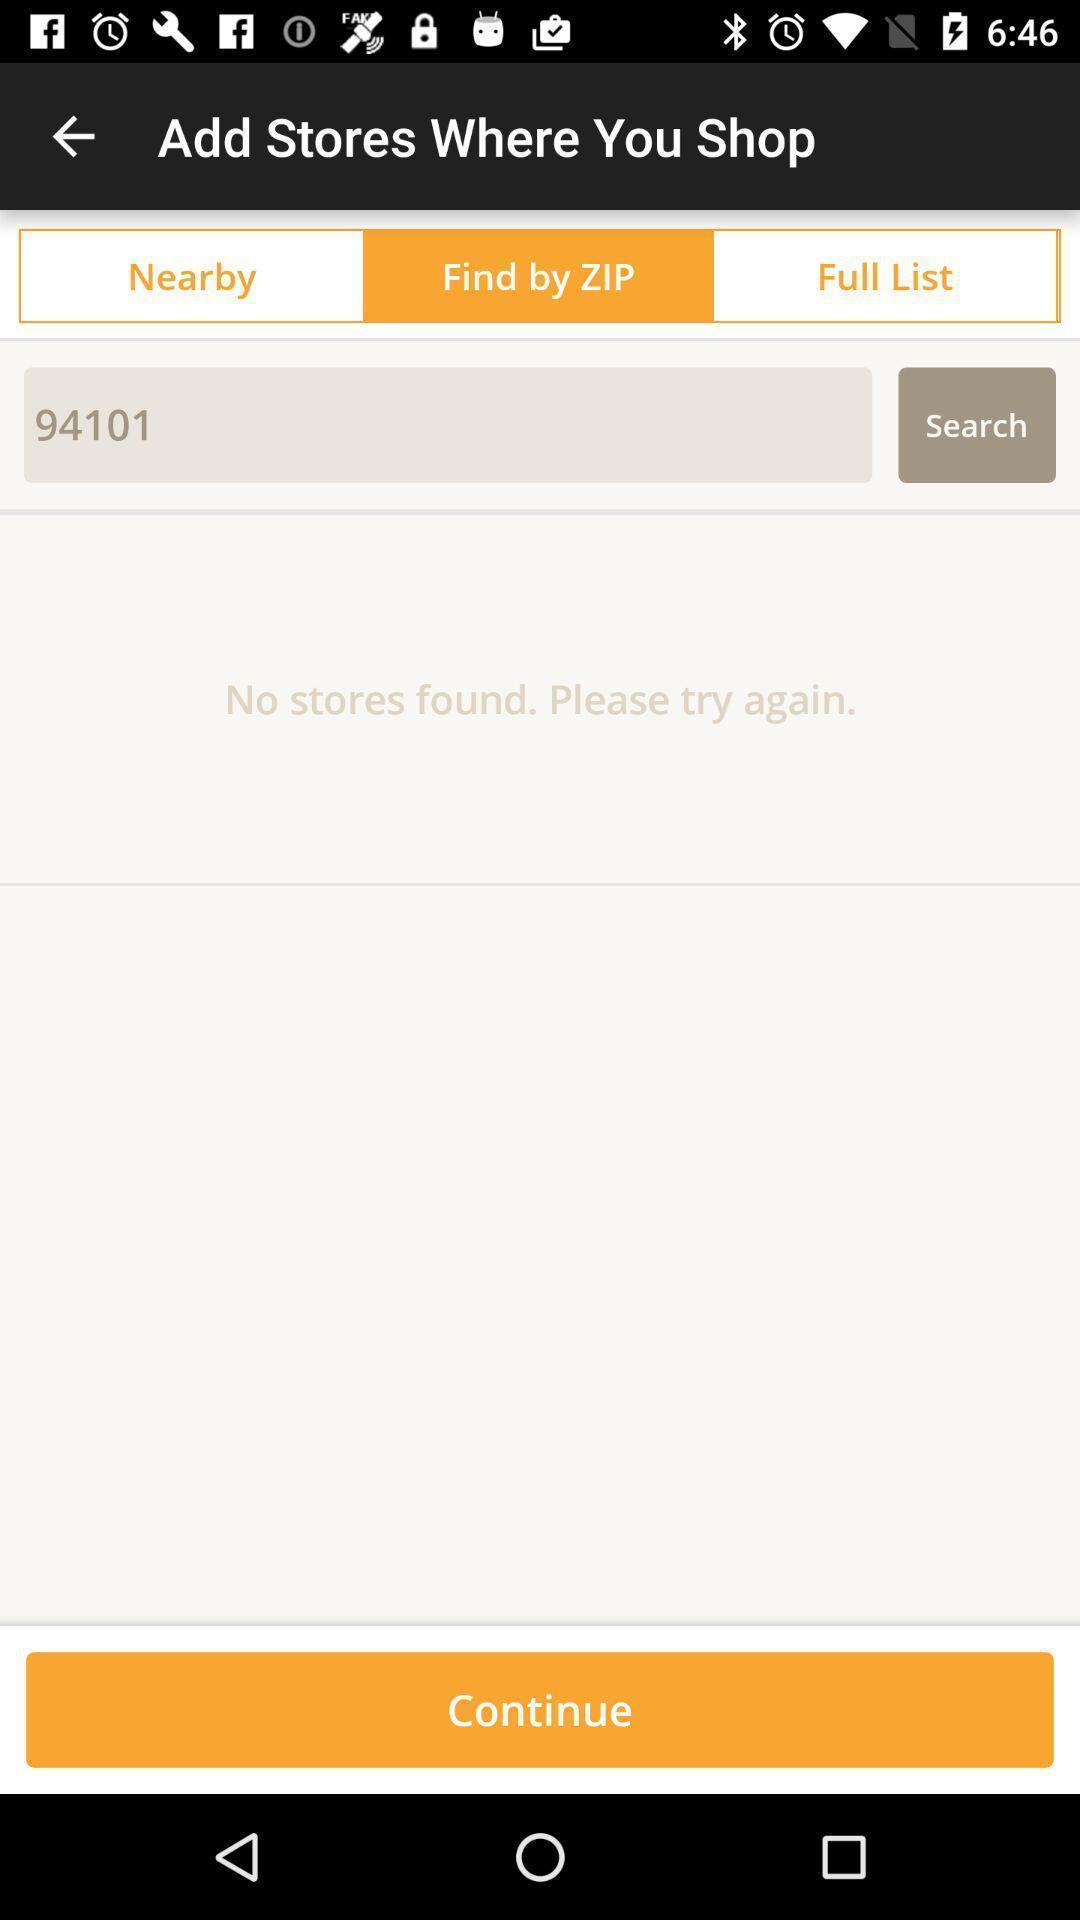Explain the elements present in this screenshot. Search page displayed using zip code. 